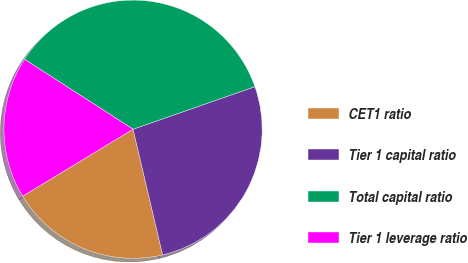Convert chart to OTSL. <chart><loc_0><loc_0><loc_500><loc_500><pie_chart><fcel>CET1 ratio<fcel>Tier 1 capital ratio<fcel>Total capital ratio<fcel>Tier 1 leverage ratio<nl><fcel>20.0%<fcel>26.67%<fcel>35.56%<fcel>17.78%<nl></chart> 